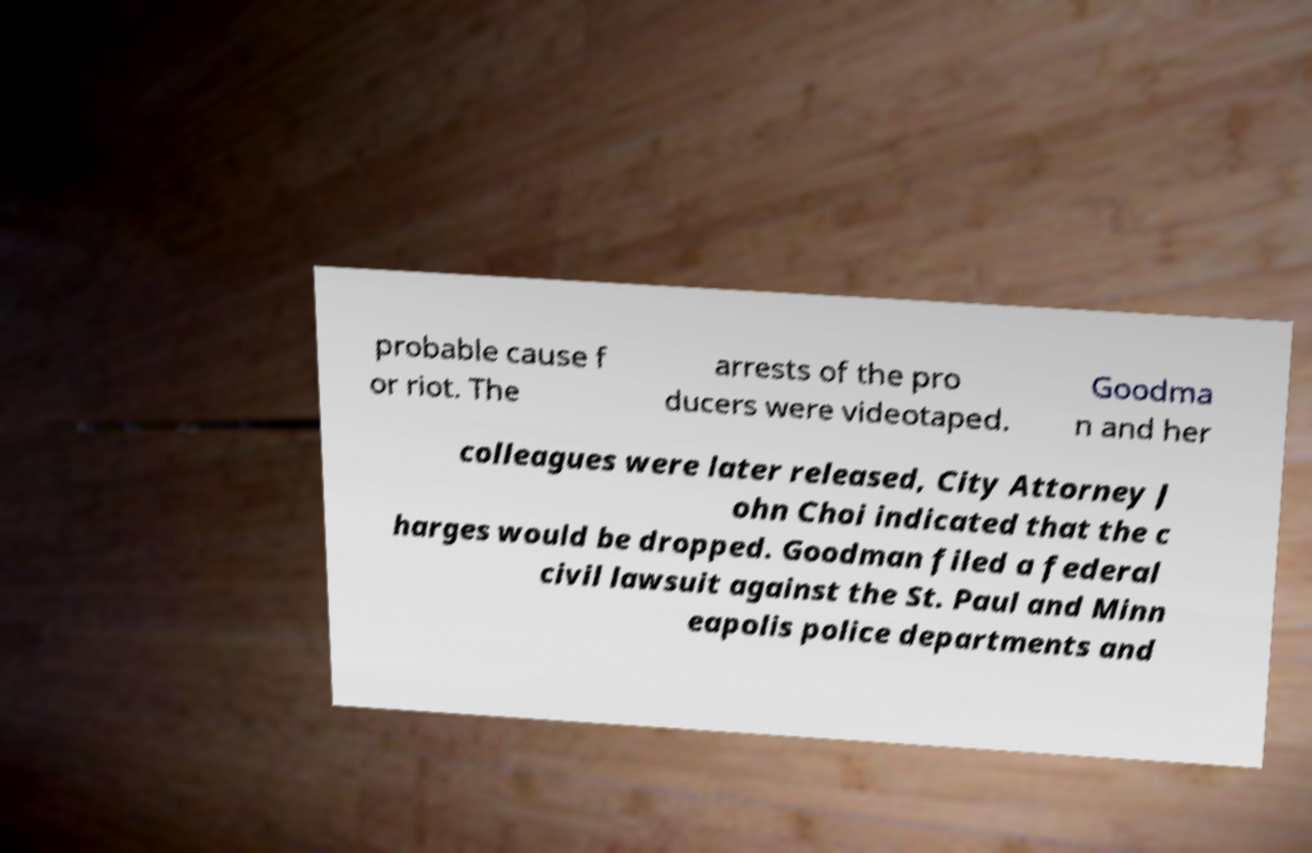I need the written content from this picture converted into text. Can you do that? probable cause f or riot. The arrests of the pro ducers were videotaped. Goodma n and her colleagues were later released, City Attorney J ohn Choi indicated that the c harges would be dropped. Goodman filed a federal civil lawsuit against the St. Paul and Minn eapolis police departments and 